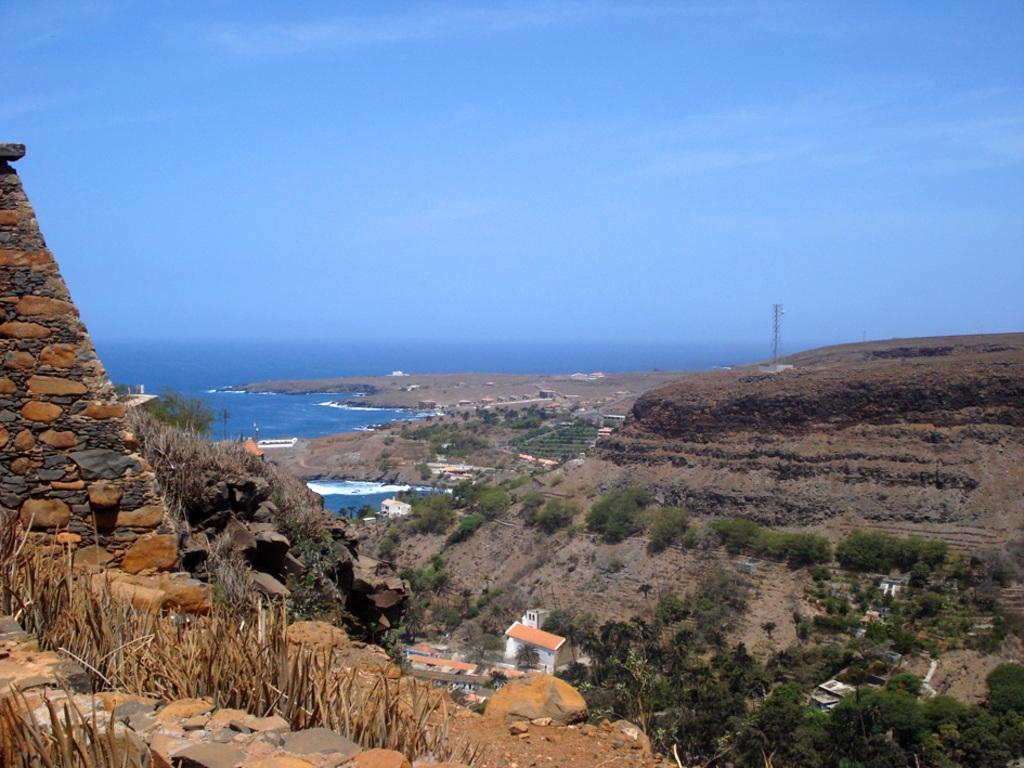What type of natural environment is depicted in the image? The image contains a sea, trees, plants, and mountains, which are all elements of a natural environment. Are there any man-made structures visible in the image? Yes, there are houses in the image. What type of vegetation can be seen in the image? Trees and plants are visible in the image. What type of berry is being used to write on the houses in the image? There is no berry present in the image, and no writing on the houses is depicted. Can you describe the coughing pattern of the mountains in the image? There is no coughing depicted in the image, as mountains are inanimate objects and do not have the ability to cough. 